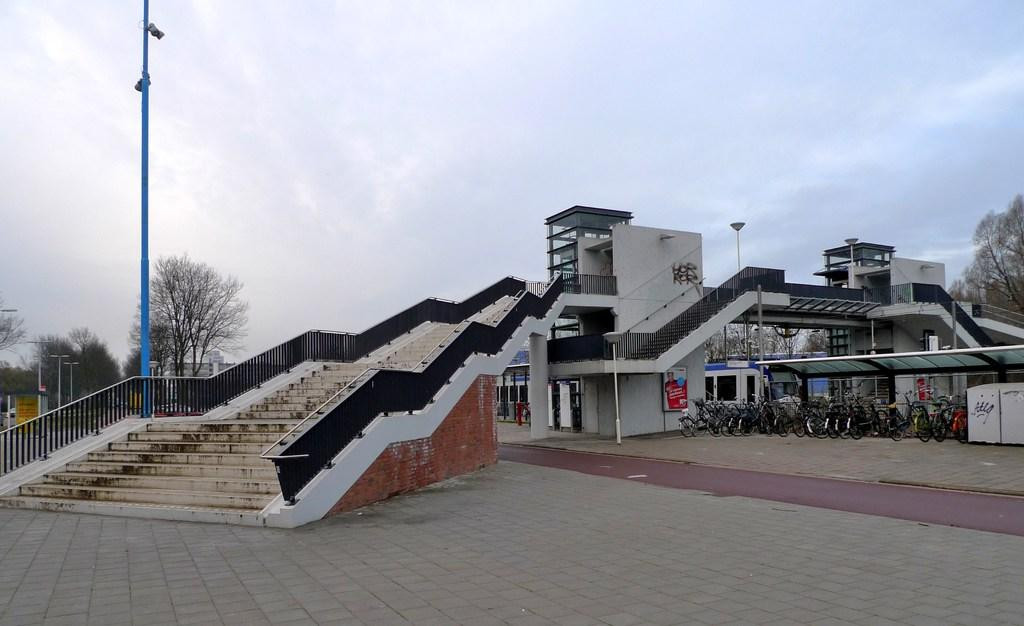What type of structure is visible in the image? There is a building with windows in the image. What architectural feature can be seen in the building? There is a staircase in the image. What mode of transportation is parked in the image? There are bicycles parked in the image. What are the poles used for in the image? The purpose of the poles is not specified in the image. What type of vegetation is present in the image? There is a group of trees in the image. What part of the natural environment is visible in the image? The sky is visible in the image. What type of thunder can be heard in the image? There is no sound present in the image, so it is not possible to determine if any thunder can be heard. 